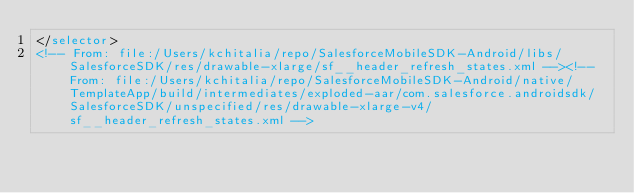<code> <loc_0><loc_0><loc_500><loc_500><_XML_></selector>
<!-- From: file:/Users/kchitalia/repo/SalesforceMobileSDK-Android/libs/SalesforceSDK/res/drawable-xlarge/sf__header_refresh_states.xml --><!-- From: file:/Users/kchitalia/repo/SalesforceMobileSDK-Android/native/TemplateApp/build/intermediates/exploded-aar/com.salesforce.androidsdk/SalesforceSDK/unspecified/res/drawable-xlarge-v4/sf__header_refresh_states.xml --></code> 